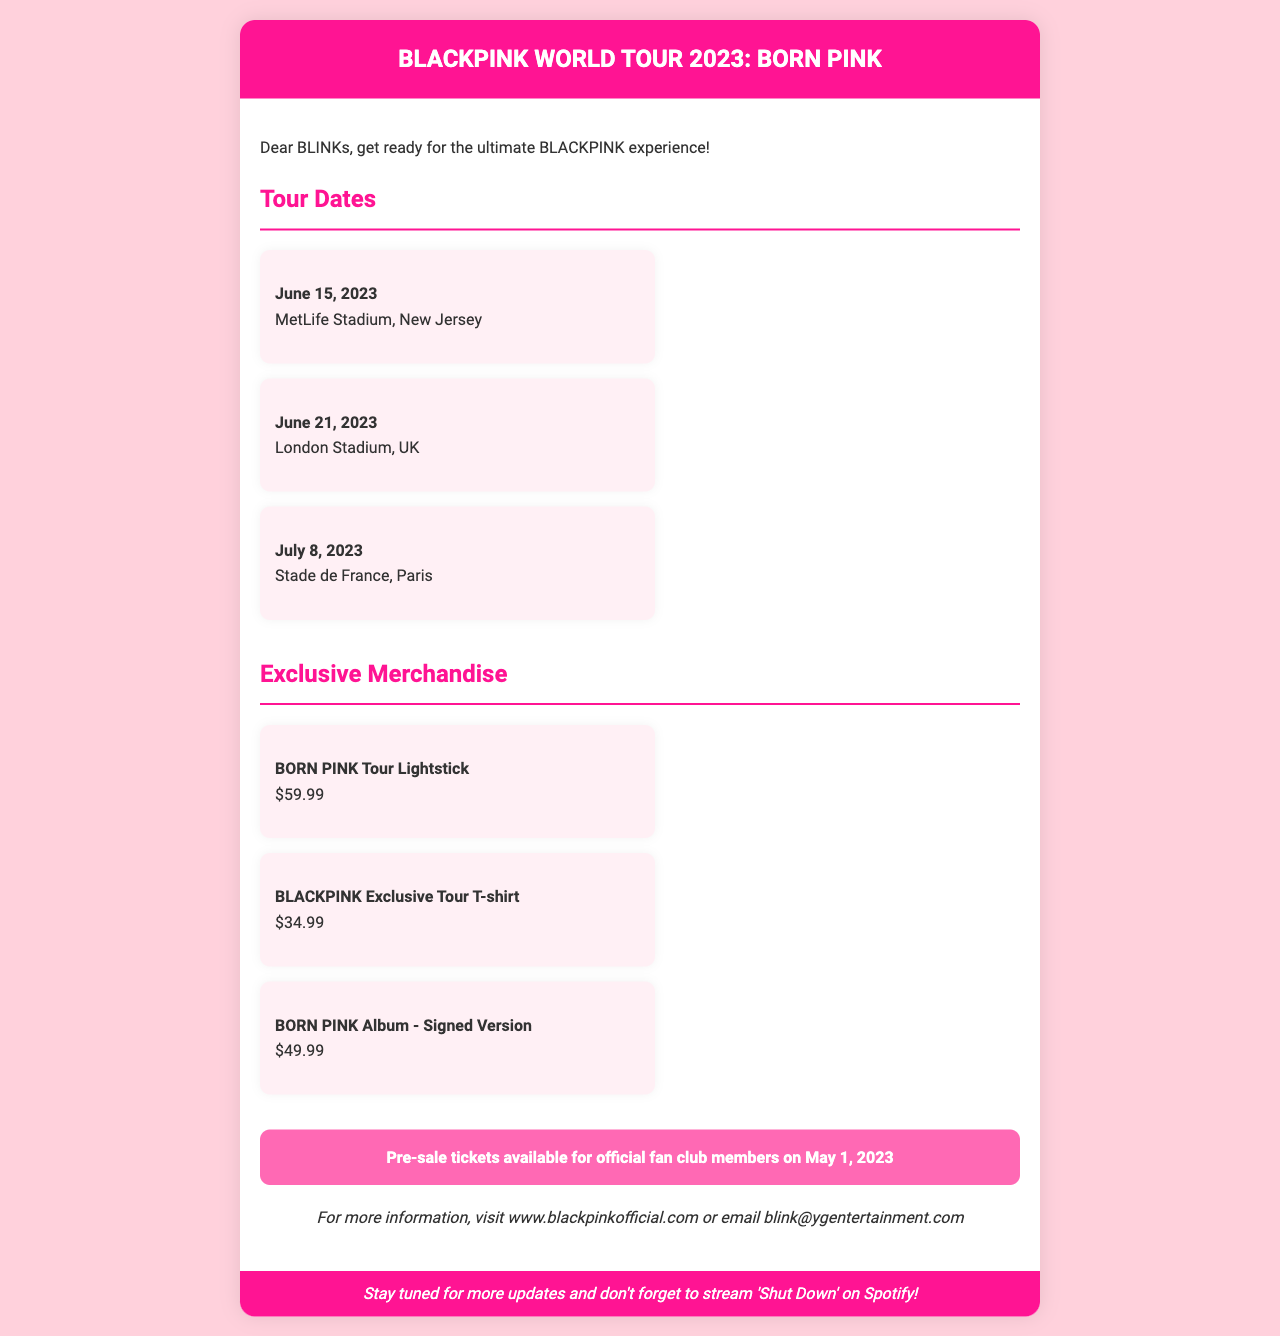What is the title of the tour? The title of the tour is prominently displayed in the header of the document, which is "BLACKPINK WORLD TOUR 2023: BORN PINK".
Answer: BLACKPINK WORLD TOUR 2023: BORN PINK When are the pre-sale tickets available? The document specifies that pre-sale tickets for official fan club members are available on May 1, 2023.
Answer: May 1, 2023 What is the cost of the BORN PINK Tour Lightstick? The document lists the price of the BORN PINK Tour Lightstick under exclusive merchandise.
Answer: $59.99 Where is the concert on July 8, 2023? The document indicates that the concert on July 8, 2023, will be held at Stade de France, Paris.
Answer: Stade de France, Paris Which merchandise item is signed? The document mentions that the BORN PINK Album - Signed Version is available as a merchandise option.
Answer: BORN PINK Album - Signed Version How many tour dates are listed in the document? By counting the listed tour dates under the "Tour Dates" section, there are three dates mentioned in the document.
Answer: 3 What color is the background of the document? The background color of the document is specified in the body style as "#FFD1DC".
Answer: #FFD1DC What is the footer message about? The footer contains a message encouraging fans to stay tuned for updates and to stream a specific song.
Answer: Stream 'Shut Down' on Spotify! 